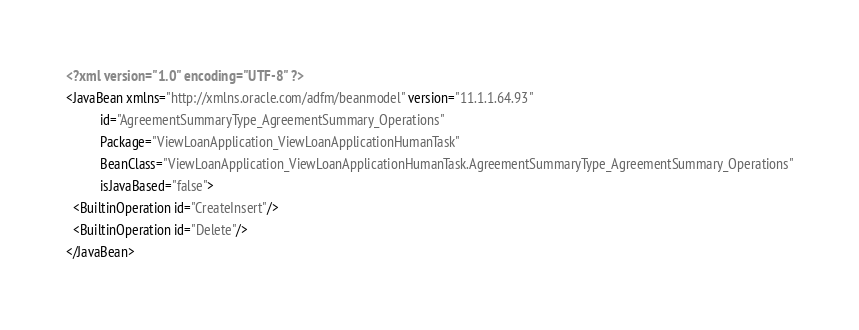Convert code to text. <code><loc_0><loc_0><loc_500><loc_500><_XML_><?xml version="1.0" encoding="UTF-8" ?>
<JavaBean xmlns="http://xmlns.oracle.com/adfm/beanmodel" version="11.1.1.64.93"
          id="AgreementSummaryType_AgreementSummary_Operations"
          Package="ViewLoanApplication_ViewLoanApplicationHumanTask"
          BeanClass="ViewLoanApplication_ViewLoanApplicationHumanTask.AgreementSummaryType_AgreementSummary_Operations"
          isJavaBased="false">
  <BuiltinOperation id="CreateInsert"/>
  <BuiltinOperation id="Delete"/>
</JavaBean>
</code> 